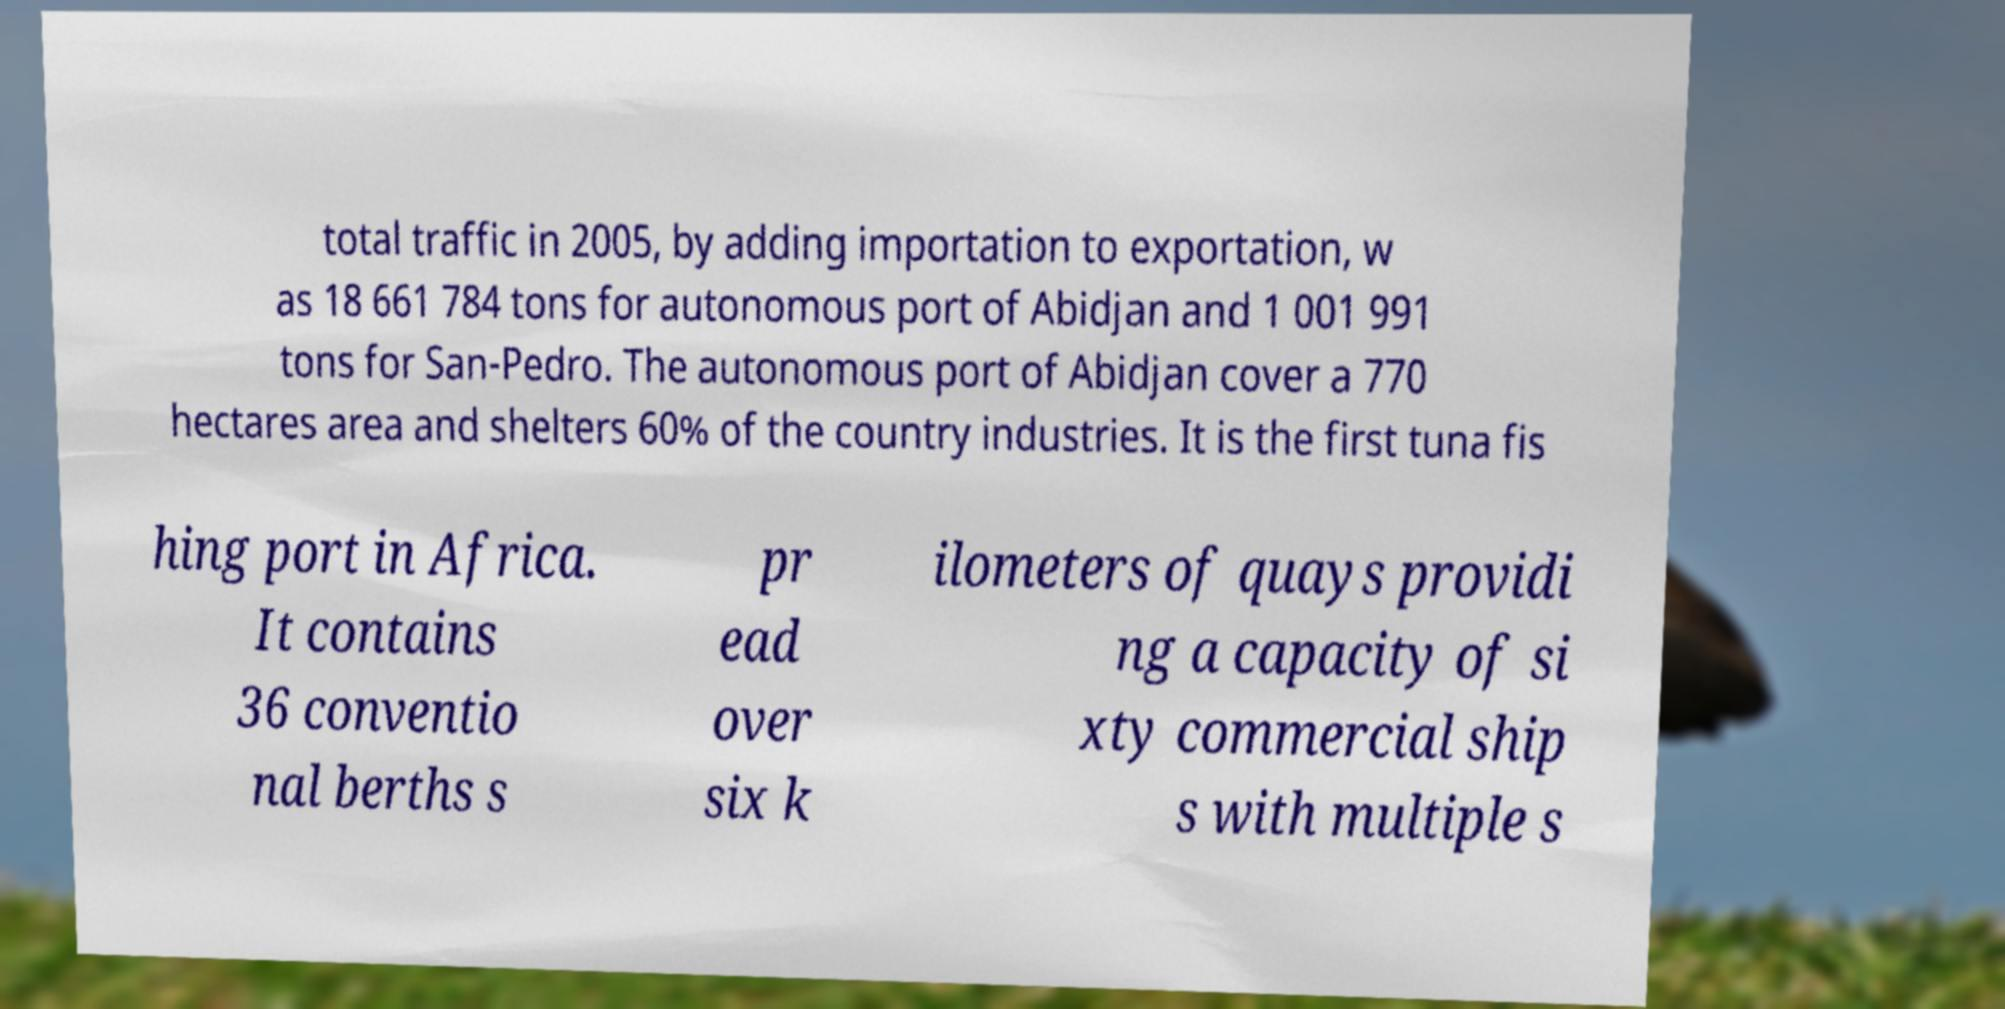Can you accurately transcribe the text from the provided image for me? total traffic in 2005, by adding importation to exportation, w as 18 661 784 tons for autonomous port of Abidjan and 1 001 991 tons for San-Pedro. The autonomous port of Abidjan cover a 770 hectares area and shelters 60% of the country industries. It is the first tuna fis hing port in Africa. It contains 36 conventio nal berths s pr ead over six k ilometers of quays providi ng a capacity of si xty commercial ship s with multiple s 